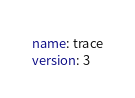<code> <loc_0><loc_0><loc_500><loc_500><_YAML_>name: trace
version: 3</code> 